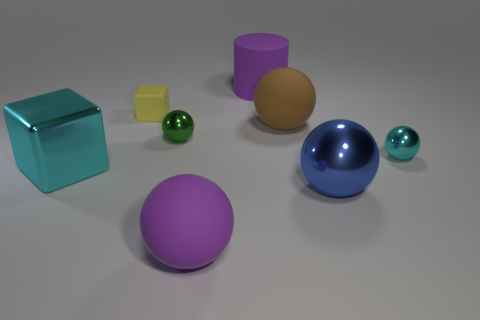Subtract all cyan balls. Subtract all red cubes. How many balls are left? 4 Add 2 yellow matte objects. How many objects exist? 10 Subtract all cylinders. How many objects are left? 7 Add 6 tiny green cubes. How many tiny green cubes exist? 6 Subtract 0 cyan cylinders. How many objects are left? 8 Subtract all large yellow matte spheres. Subtract all large cyan blocks. How many objects are left? 7 Add 1 big cyan metal things. How many big cyan metal things are left? 2 